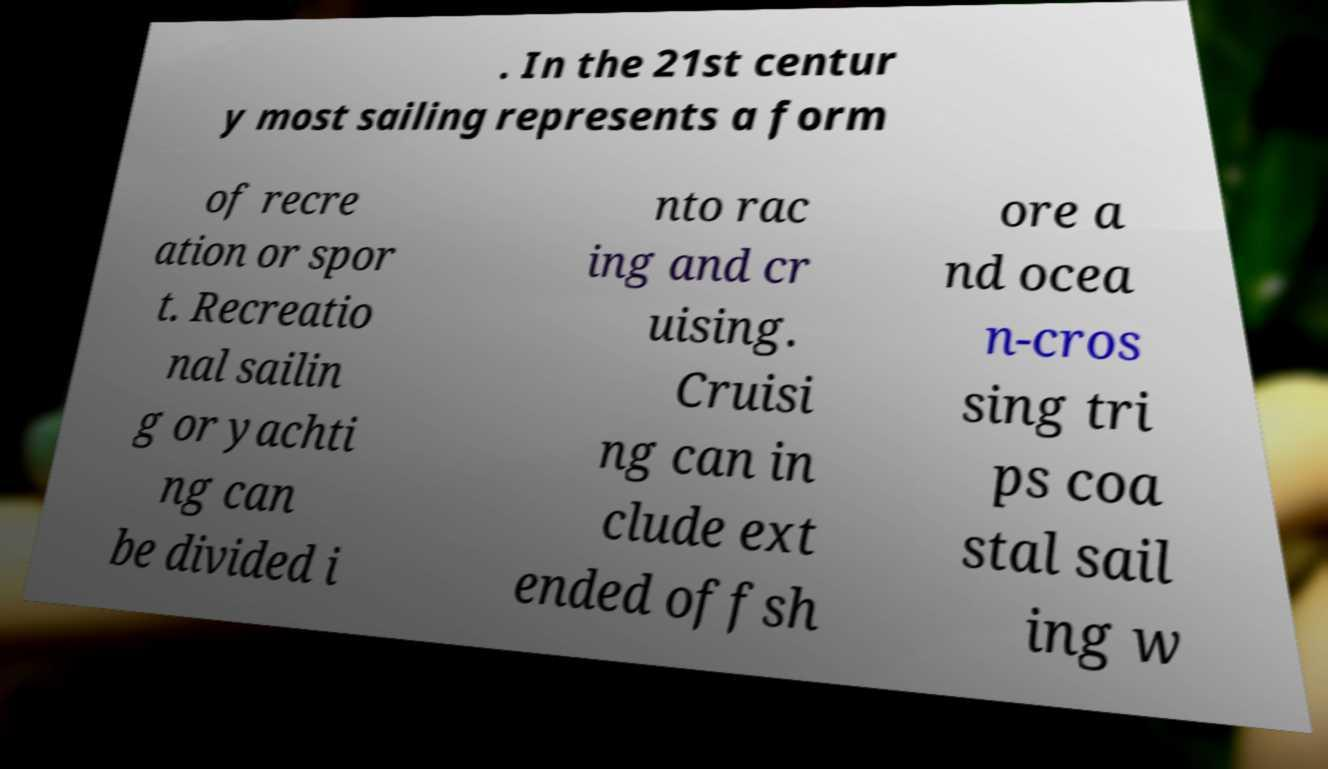Please read and relay the text visible in this image. What does it say? . In the 21st centur y most sailing represents a form of recre ation or spor t. Recreatio nal sailin g or yachti ng can be divided i nto rac ing and cr uising. Cruisi ng can in clude ext ended offsh ore a nd ocea n-cros sing tri ps coa stal sail ing w 